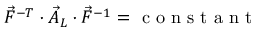<formula> <loc_0><loc_0><loc_500><loc_500>\vec { F } ^ { - T } \cdot \vec { A } _ { L } \cdot \vec { F } ^ { - 1 } = c o n s t a n t</formula> 